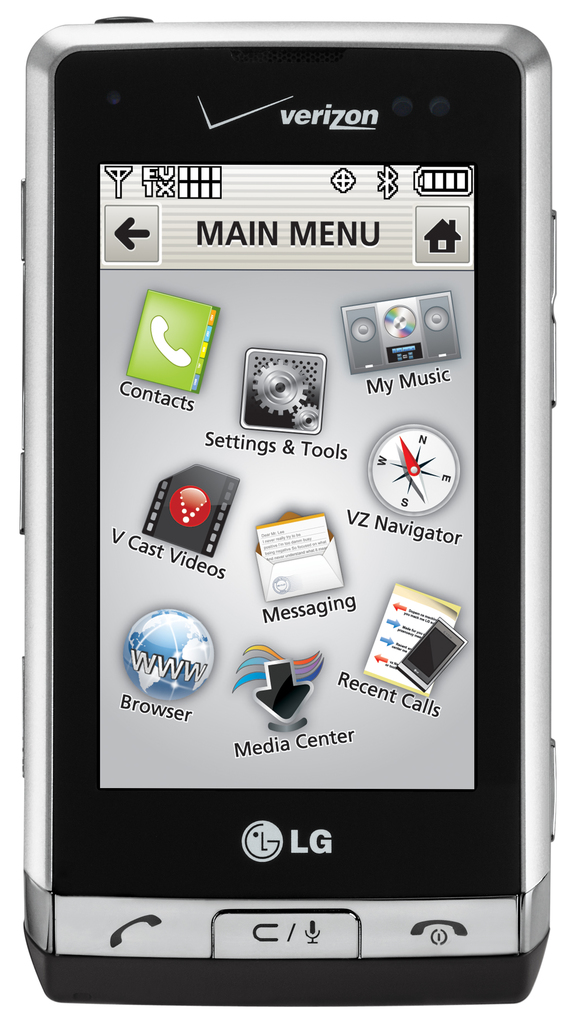Provide a one-sentence caption for the provided image.
Reference OCR token: verizon, EUOII, XO, B, I, ←, MAIN, MENU, Contacts, My, Music, Settings, &, Tools, VZ, Navigator, Cast, Videos, Messaging, ing, Recent, Calls, Browser, Media, Center, LG, C4 A verizon supported LG phone with the main menu on the screen. 